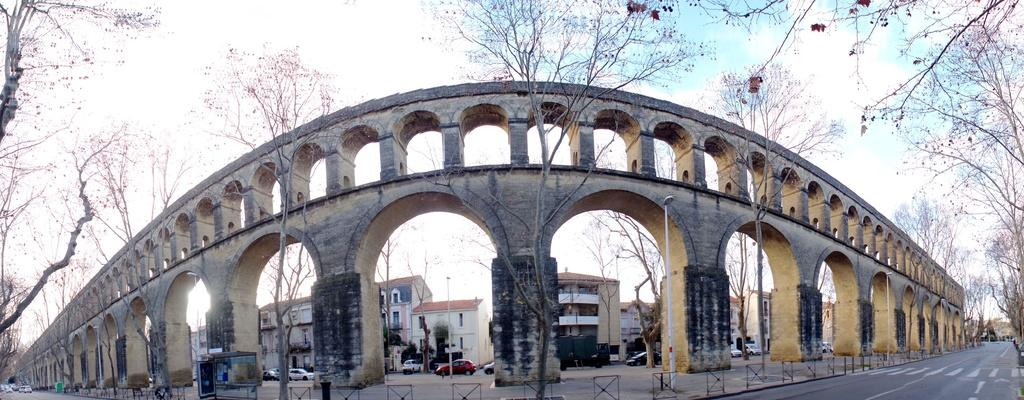What type of structures can be seen in the image? There are buildings in the image. What else can be seen moving in the image? There are vehicles in the image. What surface do the vehicles and buildings appear to be situated on? There is a road in the image. What type of vegetation is present in the image? There are trees in the image. What type of vehicles are visible in the image? There are cars in the image. What else can be seen standing upright in the image? There are poles in the image. What is visible above the buildings, vehicles, and trees? The sky is visible in the image. What can be observed in the sky? Clouds are present in the sky. Can you tell me the value of the dime on the pole in the image? There is no dime present on any of the poles in the image. What advice is being given by the buildings in the image? The buildings in the image are not giving any advice; they are stationary structures. 